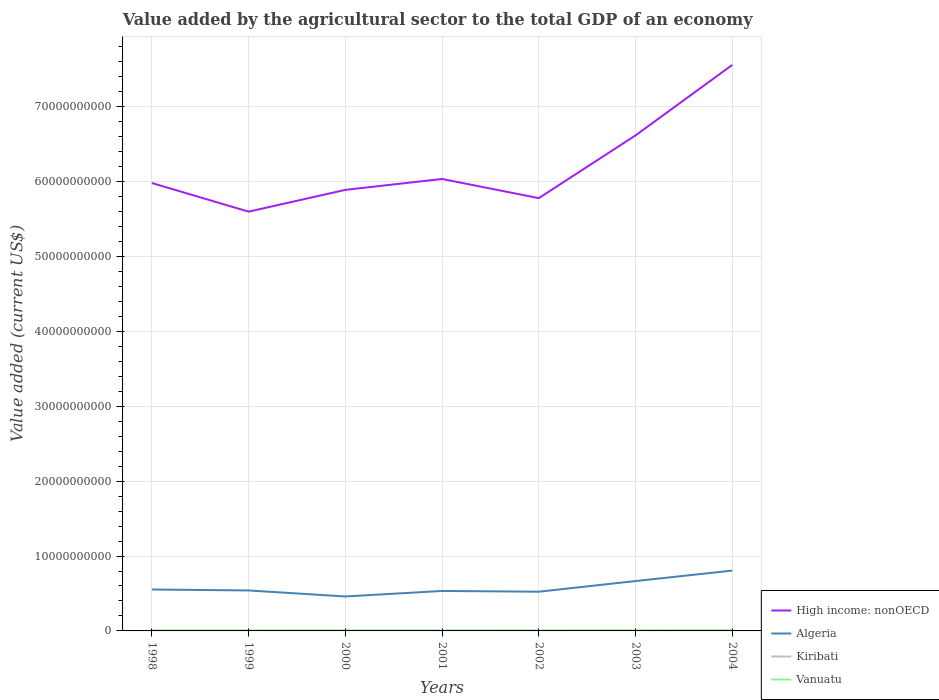How many different coloured lines are there?
Provide a short and direct response. 4. Does the line corresponding to Vanuatu intersect with the line corresponding to High income: nonOECD?
Make the answer very short. No. Across all years, what is the maximum value added by the agricultural sector to the total GDP in Algeria?
Your answer should be very brief. 4.60e+09. What is the total value added by the agricultural sector to the total GDP in High income: nonOECD in the graph?
Provide a short and direct response. 3.82e+09. What is the difference between the highest and the second highest value added by the agricultural sector to the total GDP in Vanuatu?
Give a very brief answer. 2.54e+07. Is the value added by the agricultural sector to the total GDP in Algeria strictly greater than the value added by the agricultural sector to the total GDP in Vanuatu over the years?
Offer a terse response. No. How many years are there in the graph?
Your response must be concise. 7. What is the difference between two consecutive major ticks on the Y-axis?
Give a very brief answer. 1.00e+1. Are the values on the major ticks of Y-axis written in scientific E-notation?
Your response must be concise. No. Does the graph contain grids?
Provide a short and direct response. Yes. How many legend labels are there?
Provide a succinct answer. 4. What is the title of the graph?
Provide a short and direct response. Value added by the agricultural sector to the total GDP of an economy. Does "Armenia" appear as one of the legend labels in the graph?
Your answer should be compact. No. What is the label or title of the X-axis?
Give a very brief answer. Years. What is the label or title of the Y-axis?
Offer a terse response. Value added (current US$). What is the Value added (current US$) of High income: nonOECD in 1998?
Provide a succinct answer. 5.98e+1. What is the Value added (current US$) in Algeria in 1998?
Your answer should be very brief. 5.53e+09. What is the Value added (current US$) of Kiribati in 1998?
Give a very brief answer. 1.59e+07. What is the Value added (current US$) in Vanuatu in 1998?
Your response must be concise. 6.85e+07. What is the Value added (current US$) in High income: nonOECD in 1999?
Ensure brevity in your answer.  5.60e+1. What is the Value added (current US$) in Algeria in 1999?
Your answer should be very brief. 5.40e+09. What is the Value added (current US$) of Kiribati in 1999?
Give a very brief answer. 1.74e+07. What is the Value added (current US$) of Vanuatu in 1999?
Provide a short and direct response. 6.66e+07. What is the Value added (current US$) of High income: nonOECD in 2000?
Ensure brevity in your answer.  5.89e+1. What is the Value added (current US$) of Algeria in 2000?
Offer a terse response. 4.60e+09. What is the Value added (current US$) of Kiribati in 2000?
Your answer should be compact. 1.34e+07. What is the Value added (current US$) in Vanuatu in 2000?
Offer a very short reply. 6.25e+07. What is the Value added (current US$) of High income: nonOECD in 2001?
Offer a very short reply. 6.03e+1. What is the Value added (current US$) of Algeria in 2001?
Your answer should be very brief. 5.34e+09. What is the Value added (current US$) in Kiribati in 2001?
Your answer should be very brief. 1.29e+07. What is the Value added (current US$) in Vanuatu in 2001?
Make the answer very short. 6.07e+07. What is the Value added (current US$) in High income: nonOECD in 2002?
Provide a succinct answer. 5.78e+1. What is the Value added (current US$) of Algeria in 2002?
Your answer should be very brief. 5.24e+09. What is the Value added (current US$) of Kiribati in 2002?
Give a very brief answer. 1.56e+07. What is the Value added (current US$) of Vanuatu in 2002?
Ensure brevity in your answer.  6.37e+07. What is the Value added (current US$) of High income: nonOECD in 2003?
Your answer should be compact. 6.62e+1. What is the Value added (current US$) in Algeria in 2003?
Ensure brevity in your answer.  6.66e+09. What is the Value added (current US$) in Kiribati in 2003?
Ensure brevity in your answer.  2.12e+07. What is the Value added (current US$) of Vanuatu in 2003?
Ensure brevity in your answer.  7.18e+07. What is the Value added (current US$) of High income: nonOECD in 2004?
Provide a short and direct response. 7.56e+1. What is the Value added (current US$) of Algeria in 2004?
Offer a very short reply. 8.06e+09. What is the Value added (current US$) in Kiribati in 2004?
Your response must be concise. 2.50e+07. What is the Value added (current US$) of Vanuatu in 2004?
Make the answer very short. 8.61e+07. Across all years, what is the maximum Value added (current US$) of High income: nonOECD?
Your answer should be compact. 7.56e+1. Across all years, what is the maximum Value added (current US$) of Algeria?
Offer a very short reply. 8.06e+09. Across all years, what is the maximum Value added (current US$) of Kiribati?
Provide a short and direct response. 2.50e+07. Across all years, what is the maximum Value added (current US$) in Vanuatu?
Offer a terse response. 8.61e+07. Across all years, what is the minimum Value added (current US$) in High income: nonOECD?
Ensure brevity in your answer.  5.60e+1. Across all years, what is the minimum Value added (current US$) in Algeria?
Make the answer very short. 4.60e+09. Across all years, what is the minimum Value added (current US$) in Kiribati?
Provide a short and direct response. 1.29e+07. Across all years, what is the minimum Value added (current US$) of Vanuatu?
Provide a succinct answer. 6.07e+07. What is the total Value added (current US$) in High income: nonOECD in the graph?
Provide a short and direct response. 4.35e+11. What is the total Value added (current US$) of Algeria in the graph?
Provide a short and direct response. 4.08e+1. What is the total Value added (current US$) in Kiribati in the graph?
Provide a succinct answer. 1.21e+08. What is the total Value added (current US$) of Vanuatu in the graph?
Make the answer very short. 4.80e+08. What is the difference between the Value added (current US$) in High income: nonOECD in 1998 and that in 1999?
Give a very brief answer. 3.82e+09. What is the difference between the Value added (current US$) of Algeria in 1998 and that in 1999?
Provide a short and direct response. 1.27e+08. What is the difference between the Value added (current US$) of Kiribati in 1998 and that in 1999?
Provide a succinct answer. -1.44e+06. What is the difference between the Value added (current US$) of Vanuatu in 1998 and that in 1999?
Offer a very short reply. 1.86e+06. What is the difference between the Value added (current US$) in High income: nonOECD in 1998 and that in 2000?
Offer a terse response. 9.12e+08. What is the difference between the Value added (current US$) in Algeria in 1998 and that in 2000?
Keep it short and to the point. 9.29e+08. What is the difference between the Value added (current US$) in Kiribati in 1998 and that in 2000?
Your answer should be compact. 2.51e+06. What is the difference between the Value added (current US$) of Vanuatu in 1998 and that in 2000?
Offer a very short reply. 5.99e+06. What is the difference between the Value added (current US$) in High income: nonOECD in 1998 and that in 2001?
Offer a very short reply. -5.42e+08. What is the difference between the Value added (current US$) in Algeria in 1998 and that in 2001?
Your response must be concise. 1.92e+08. What is the difference between the Value added (current US$) in Kiribati in 1998 and that in 2001?
Provide a succinct answer. 3.06e+06. What is the difference between the Value added (current US$) of Vanuatu in 1998 and that in 2001?
Your answer should be compact. 7.76e+06. What is the difference between the Value added (current US$) of High income: nonOECD in 1998 and that in 2002?
Make the answer very short. 2.02e+09. What is the difference between the Value added (current US$) of Algeria in 1998 and that in 2002?
Keep it short and to the point. 2.93e+08. What is the difference between the Value added (current US$) of Kiribati in 1998 and that in 2002?
Your answer should be compact. 2.98e+05. What is the difference between the Value added (current US$) of Vanuatu in 1998 and that in 2002?
Your answer should be very brief. 4.73e+06. What is the difference between the Value added (current US$) in High income: nonOECD in 1998 and that in 2003?
Offer a terse response. -6.36e+09. What is the difference between the Value added (current US$) in Algeria in 1998 and that in 2003?
Your answer should be compact. -1.13e+09. What is the difference between the Value added (current US$) in Kiribati in 1998 and that in 2003?
Give a very brief answer. -5.22e+06. What is the difference between the Value added (current US$) of Vanuatu in 1998 and that in 2003?
Your answer should be very brief. -3.34e+06. What is the difference between the Value added (current US$) of High income: nonOECD in 1998 and that in 2004?
Give a very brief answer. -1.58e+1. What is the difference between the Value added (current US$) of Algeria in 1998 and that in 2004?
Give a very brief answer. -2.53e+09. What is the difference between the Value added (current US$) of Kiribati in 1998 and that in 2004?
Offer a terse response. -9.05e+06. What is the difference between the Value added (current US$) in Vanuatu in 1998 and that in 2004?
Provide a succinct answer. -1.77e+07. What is the difference between the Value added (current US$) in High income: nonOECD in 1999 and that in 2000?
Provide a succinct answer. -2.91e+09. What is the difference between the Value added (current US$) in Algeria in 1999 and that in 2000?
Your answer should be compact. 8.03e+08. What is the difference between the Value added (current US$) of Kiribati in 1999 and that in 2000?
Provide a succinct answer. 3.95e+06. What is the difference between the Value added (current US$) of Vanuatu in 1999 and that in 2000?
Give a very brief answer. 4.12e+06. What is the difference between the Value added (current US$) of High income: nonOECD in 1999 and that in 2001?
Offer a very short reply. -4.36e+09. What is the difference between the Value added (current US$) in Algeria in 1999 and that in 2001?
Your response must be concise. 6.57e+07. What is the difference between the Value added (current US$) of Kiribati in 1999 and that in 2001?
Provide a short and direct response. 4.50e+06. What is the difference between the Value added (current US$) in Vanuatu in 1999 and that in 2001?
Offer a very short reply. 5.90e+06. What is the difference between the Value added (current US$) of High income: nonOECD in 1999 and that in 2002?
Your answer should be compact. -1.80e+09. What is the difference between the Value added (current US$) of Algeria in 1999 and that in 2002?
Provide a short and direct response. 1.67e+08. What is the difference between the Value added (current US$) in Kiribati in 1999 and that in 2002?
Make the answer very short. 1.74e+06. What is the difference between the Value added (current US$) in Vanuatu in 1999 and that in 2002?
Give a very brief answer. 2.87e+06. What is the difference between the Value added (current US$) in High income: nonOECD in 1999 and that in 2003?
Your response must be concise. -1.02e+1. What is the difference between the Value added (current US$) in Algeria in 1999 and that in 2003?
Provide a succinct answer. -1.25e+09. What is the difference between the Value added (current US$) of Kiribati in 1999 and that in 2003?
Ensure brevity in your answer.  -3.79e+06. What is the difference between the Value added (current US$) of Vanuatu in 1999 and that in 2003?
Make the answer very short. -5.20e+06. What is the difference between the Value added (current US$) of High income: nonOECD in 1999 and that in 2004?
Provide a succinct answer. -1.96e+1. What is the difference between the Value added (current US$) of Algeria in 1999 and that in 2004?
Your answer should be very brief. -2.65e+09. What is the difference between the Value added (current US$) of Kiribati in 1999 and that in 2004?
Offer a terse response. -7.61e+06. What is the difference between the Value added (current US$) of Vanuatu in 1999 and that in 2004?
Your answer should be very brief. -1.95e+07. What is the difference between the Value added (current US$) in High income: nonOECD in 2000 and that in 2001?
Your response must be concise. -1.45e+09. What is the difference between the Value added (current US$) of Algeria in 2000 and that in 2001?
Your response must be concise. -7.37e+08. What is the difference between the Value added (current US$) of Kiribati in 2000 and that in 2001?
Provide a succinct answer. 5.52e+05. What is the difference between the Value added (current US$) in Vanuatu in 2000 and that in 2001?
Your answer should be compact. 1.78e+06. What is the difference between the Value added (current US$) in High income: nonOECD in 2000 and that in 2002?
Provide a succinct answer. 1.11e+09. What is the difference between the Value added (current US$) in Algeria in 2000 and that in 2002?
Ensure brevity in your answer.  -6.36e+08. What is the difference between the Value added (current US$) in Kiribati in 2000 and that in 2002?
Your answer should be very brief. -2.21e+06. What is the difference between the Value added (current US$) of Vanuatu in 2000 and that in 2002?
Your answer should be very brief. -1.26e+06. What is the difference between the Value added (current US$) in High income: nonOECD in 2000 and that in 2003?
Your answer should be very brief. -7.27e+09. What is the difference between the Value added (current US$) in Algeria in 2000 and that in 2003?
Provide a short and direct response. -2.06e+09. What is the difference between the Value added (current US$) of Kiribati in 2000 and that in 2003?
Keep it short and to the point. -7.73e+06. What is the difference between the Value added (current US$) of Vanuatu in 2000 and that in 2003?
Offer a terse response. -9.32e+06. What is the difference between the Value added (current US$) of High income: nonOECD in 2000 and that in 2004?
Give a very brief answer. -1.67e+1. What is the difference between the Value added (current US$) in Algeria in 2000 and that in 2004?
Keep it short and to the point. -3.46e+09. What is the difference between the Value added (current US$) in Kiribati in 2000 and that in 2004?
Offer a terse response. -1.16e+07. What is the difference between the Value added (current US$) in Vanuatu in 2000 and that in 2004?
Provide a short and direct response. -2.37e+07. What is the difference between the Value added (current US$) of High income: nonOECD in 2001 and that in 2002?
Your answer should be compact. 2.56e+09. What is the difference between the Value added (current US$) in Algeria in 2001 and that in 2002?
Ensure brevity in your answer.  1.01e+08. What is the difference between the Value added (current US$) in Kiribati in 2001 and that in 2002?
Give a very brief answer. -2.76e+06. What is the difference between the Value added (current US$) of Vanuatu in 2001 and that in 2002?
Ensure brevity in your answer.  -3.03e+06. What is the difference between the Value added (current US$) in High income: nonOECD in 2001 and that in 2003?
Give a very brief answer. -5.82e+09. What is the difference between the Value added (current US$) of Algeria in 2001 and that in 2003?
Provide a succinct answer. -1.32e+09. What is the difference between the Value added (current US$) in Kiribati in 2001 and that in 2003?
Provide a short and direct response. -8.29e+06. What is the difference between the Value added (current US$) in Vanuatu in 2001 and that in 2003?
Your response must be concise. -1.11e+07. What is the difference between the Value added (current US$) of High income: nonOECD in 2001 and that in 2004?
Give a very brief answer. -1.52e+1. What is the difference between the Value added (current US$) in Algeria in 2001 and that in 2004?
Keep it short and to the point. -2.72e+09. What is the difference between the Value added (current US$) in Kiribati in 2001 and that in 2004?
Offer a very short reply. -1.21e+07. What is the difference between the Value added (current US$) of Vanuatu in 2001 and that in 2004?
Provide a short and direct response. -2.54e+07. What is the difference between the Value added (current US$) of High income: nonOECD in 2002 and that in 2003?
Provide a succinct answer. -8.38e+09. What is the difference between the Value added (current US$) in Algeria in 2002 and that in 2003?
Give a very brief answer. -1.42e+09. What is the difference between the Value added (current US$) of Kiribati in 2002 and that in 2003?
Offer a very short reply. -5.52e+06. What is the difference between the Value added (current US$) of Vanuatu in 2002 and that in 2003?
Give a very brief answer. -8.07e+06. What is the difference between the Value added (current US$) of High income: nonOECD in 2002 and that in 2004?
Offer a very short reply. -1.78e+1. What is the difference between the Value added (current US$) in Algeria in 2002 and that in 2004?
Your answer should be very brief. -2.82e+09. What is the difference between the Value added (current US$) in Kiribati in 2002 and that in 2004?
Make the answer very short. -9.35e+06. What is the difference between the Value added (current US$) in Vanuatu in 2002 and that in 2004?
Your answer should be compact. -2.24e+07. What is the difference between the Value added (current US$) in High income: nonOECD in 2003 and that in 2004?
Ensure brevity in your answer.  -9.41e+09. What is the difference between the Value added (current US$) of Algeria in 2003 and that in 2004?
Provide a succinct answer. -1.40e+09. What is the difference between the Value added (current US$) of Kiribati in 2003 and that in 2004?
Your answer should be very brief. -3.82e+06. What is the difference between the Value added (current US$) in Vanuatu in 2003 and that in 2004?
Offer a very short reply. -1.43e+07. What is the difference between the Value added (current US$) in High income: nonOECD in 1998 and the Value added (current US$) in Algeria in 1999?
Ensure brevity in your answer.  5.44e+1. What is the difference between the Value added (current US$) of High income: nonOECD in 1998 and the Value added (current US$) of Kiribati in 1999?
Give a very brief answer. 5.98e+1. What is the difference between the Value added (current US$) in High income: nonOECD in 1998 and the Value added (current US$) in Vanuatu in 1999?
Keep it short and to the point. 5.97e+1. What is the difference between the Value added (current US$) in Algeria in 1998 and the Value added (current US$) in Kiribati in 1999?
Offer a very short reply. 5.51e+09. What is the difference between the Value added (current US$) of Algeria in 1998 and the Value added (current US$) of Vanuatu in 1999?
Give a very brief answer. 5.46e+09. What is the difference between the Value added (current US$) in Kiribati in 1998 and the Value added (current US$) in Vanuatu in 1999?
Make the answer very short. -5.07e+07. What is the difference between the Value added (current US$) in High income: nonOECD in 1998 and the Value added (current US$) in Algeria in 2000?
Give a very brief answer. 5.52e+1. What is the difference between the Value added (current US$) in High income: nonOECD in 1998 and the Value added (current US$) in Kiribati in 2000?
Offer a terse response. 5.98e+1. What is the difference between the Value added (current US$) in High income: nonOECD in 1998 and the Value added (current US$) in Vanuatu in 2000?
Ensure brevity in your answer.  5.97e+1. What is the difference between the Value added (current US$) in Algeria in 1998 and the Value added (current US$) in Kiribati in 2000?
Offer a terse response. 5.52e+09. What is the difference between the Value added (current US$) of Algeria in 1998 and the Value added (current US$) of Vanuatu in 2000?
Keep it short and to the point. 5.47e+09. What is the difference between the Value added (current US$) of Kiribati in 1998 and the Value added (current US$) of Vanuatu in 2000?
Ensure brevity in your answer.  -4.65e+07. What is the difference between the Value added (current US$) of High income: nonOECD in 1998 and the Value added (current US$) of Algeria in 2001?
Offer a terse response. 5.45e+1. What is the difference between the Value added (current US$) in High income: nonOECD in 1998 and the Value added (current US$) in Kiribati in 2001?
Offer a terse response. 5.98e+1. What is the difference between the Value added (current US$) of High income: nonOECD in 1998 and the Value added (current US$) of Vanuatu in 2001?
Your answer should be very brief. 5.97e+1. What is the difference between the Value added (current US$) in Algeria in 1998 and the Value added (current US$) in Kiribati in 2001?
Offer a terse response. 5.52e+09. What is the difference between the Value added (current US$) in Algeria in 1998 and the Value added (current US$) in Vanuatu in 2001?
Keep it short and to the point. 5.47e+09. What is the difference between the Value added (current US$) of Kiribati in 1998 and the Value added (current US$) of Vanuatu in 2001?
Offer a very short reply. -4.48e+07. What is the difference between the Value added (current US$) in High income: nonOECD in 1998 and the Value added (current US$) in Algeria in 2002?
Offer a terse response. 5.46e+1. What is the difference between the Value added (current US$) in High income: nonOECD in 1998 and the Value added (current US$) in Kiribati in 2002?
Give a very brief answer. 5.98e+1. What is the difference between the Value added (current US$) of High income: nonOECD in 1998 and the Value added (current US$) of Vanuatu in 2002?
Keep it short and to the point. 5.97e+1. What is the difference between the Value added (current US$) in Algeria in 1998 and the Value added (current US$) in Kiribati in 2002?
Provide a succinct answer. 5.51e+09. What is the difference between the Value added (current US$) in Algeria in 1998 and the Value added (current US$) in Vanuatu in 2002?
Provide a succinct answer. 5.47e+09. What is the difference between the Value added (current US$) of Kiribati in 1998 and the Value added (current US$) of Vanuatu in 2002?
Keep it short and to the point. -4.78e+07. What is the difference between the Value added (current US$) of High income: nonOECD in 1998 and the Value added (current US$) of Algeria in 2003?
Provide a succinct answer. 5.31e+1. What is the difference between the Value added (current US$) in High income: nonOECD in 1998 and the Value added (current US$) in Kiribati in 2003?
Ensure brevity in your answer.  5.98e+1. What is the difference between the Value added (current US$) in High income: nonOECD in 1998 and the Value added (current US$) in Vanuatu in 2003?
Your response must be concise. 5.97e+1. What is the difference between the Value added (current US$) in Algeria in 1998 and the Value added (current US$) in Kiribati in 2003?
Your answer should be very brief. 5.51e+09. What is the difference between the Value added (current US$) of Algeria in 1998 and the Value added (current US$) of Vanuatu in 2003?
Make the answer very short. 5.46e+09. What is the difference between the Value added (current US$) in Kiribati in 1998 and the Value added (current US$) in Vanuatu in 2003?
Your response must be concise. -5.59e+07. What is the difference between the Value added (current US$) in High income: nonOECD in 1998 and the Value added (current US$) in Algeria in 2004?
Offer a very short reply. 5.17e+1. What is the difference between the Value added (current US$) of High income: nonOECD in 1998 and the Value added (current US$) of Kiribati in 2004?
Provide a short and direct response. 5.98e+1. What is the difference between the Value added (current US$) of High income: nonOECD in 1998 and the Value added (current US$) of Vanuatu in 2004?
Your answer should be compact. 5.97e+1. What is the difference between the Value added (current US$) in Algeria in 1998 and the Value added (current US$) in Kiribati in 2004?
Offer a very short reply. 5.50e+09. What is the difference between the Value added (current US$) of Algeria in 1998 and the Value added (current US$) of Vanuatu in 2004?
Your answer should be very brief. 5.44e+09. What is the difference between the Value added (current US$) of Kiribati in 1998 and the Value added (current US$) of Vanuatu in 2004?
Provide a succinct answer. -7.02e+07. What is the difference between the Value added (current US$) of High income: nonOECD in 1999 and the Value added (current US$) of Algeria in 2000?
Give a very brief answer. 5.14e+1. What is the difference between the Value added (current US$) in High income: nonOECD in 1999 and the Value added (current US$) in Kiribati in 2000?
Your response must be concise. 5.60e+1. What is the difference between the Value added (current US$) of High income: nonOECD in 1999 and the Value added (current US$) of Vanuatu in 2000?
Keep it short and to the point. 5.59e+1. What is the difference between the Value added (current US$) in Algeria in 1999 and the Value added (current US$) in Kiribati in 2000?
Provide a succinct answer. 5.39e+09. What is the difference between the Value added (current US$) of Algeria in 1999 and the Value added (current US$) of Vanuatu in 2000?
Make the answer very short. 5.34e+09. What is the difference between the Value added (current US$) in Kiribati in 1999 and the Value added (current US$) in Vanuatu in 2000?
Provide a succinct answer. -4.51e+07. What is the difference between the Value added (current US$) of High income: nonOECD in 1999 and the Value added (current US$) of Algeria in 2001?
Keep it short and to the point. 5.06e+1. What is the difference between the Value added (current US$) in High income: nonOECD in 1999 and the Value added (current US$) in Kiribati in 2001?
Ensure brevity in your answer.  5.60e+1. What is the difference between the Value added (current US$) in High income: nonOECD in 1999 and the Value added (current US$) in Vanuatu in 2001?
Offer a terse response. 5.59e+1. What is the difference between the Value added (current US$) in Algeria in 1999 and the Value added (current US$) in Kiribati in 2001?
Provide a short and direct response. 5.39e+09. What is the difference between the Value added (current US$) of Algeria in 1999 and the Value added (current US$) of Vanuatu in 2001?
Provide a short and direct response. 5.34e+09. What is the difference between the Value added (current US$) in Kiribati in 1999 and the Value added (current US$) in Vanuatu in 2001?
Provide a short and direct response. -4.33e+07. What is the difference between the Value added (current US$) in High income: nonOECD in 1999 and the Value added (current US$) in Algeria in 2002?
Ensure brevity in your answer.  5.07e+1. What is the difference between the Value added (current US$) of High income: nonOECD in 1999 and the Value added (current US$) of Kiribati in 2002?
Ensure brevity in your answer.  5.60e+1. What is the difference between the Value added (current US$) of High income: nonOECD in 1999 and the Value added (current US$) of Vanuatu in 2002?
Give a very brief answer. 5.59e+1. What is the difference between the Value added (current US$) in Algeria in 1999 and the Value added (current US$) in Kiribati in 2002?
Keep it short and to the point. 5.39e+09. What is the difference between the Value added (current US$) of Algeria in 1999 and the Value added (current US$) of Vanuatu in 2002?
Offer a terse response. 5.34e+09. What is the difference between the Value added (current US$) of Kiribati in 1999 and the Value added (current US$) of Vanuatu in 2002?
Offer a very short reply. -4.64e+07. What is the difference between the Value added (current US$) of High income: nonOECD in 1999 and the Value added (current US$) of Algeria in 2003?
Offer a terse response. 4.93e+1. What is the difference between the Value added (current US$) of High income: nonOECD in 1999 and the Value added (current US$) of Kiribati in 2003?
Offer a terse response. 5.60e+1. What is the difference between the Value added (current US$) in High income: nonOECD in 1999 and the Value added (current US$) in Vanuatu in 2003?
Make the answer very short. 5.59e+1. What is the difference between the Value added (current US$) in Algeria in 1999 and the Value added (current US$) in Kiribati in 2003?
Your response must be concise. 5.38e+09. What is the difference between the Value added (current US$) of Algeria in 1999 and the Value added (current US$) of Vanuatu in 2003?
Ensure brevity in your answer.  5.33e+09. What is the difference between the Value added (current US$) of Kiribati in 1999 and the Value added (current US$) of Vanuatu in 2003?
Keep it short and to the point. -5.44e+07. What is the difference between the Value added (current US$) of High income: nonOECD in 1999 and the Value added (current US$) of Algeria in 2004?
Offer a terse response. 4.79e+1. What is the difference between the Value added (current US$) in High income: nonOECD in 1999 and the Value added (current US$) in Kiribati in 2004?
Offer a terse response. 5.60e+1. What is the difference between the Value added (current US$) of High income: nonOECD in 1999 and the Value added (current US$) of Vanuatu in 2004?
Provide a short and direct response. 5.59e+1. What is the difference between the Value added (current US$) in Algeria in 1999 and the Value added (current US$) in Kiribati in 2004?
Give a very brief answer. 5.38e+09. What is the difference between the Value added (current US$) in Algeria in 1999 and the Value added (current US$) in Vanuatu in 2004?
Your answer should be compact. 5.32e+09. What is the difference between the Value added (current US$) of Kiribati in 1999 and the Value added (current US$) of Vanuatu in 2004?
Your answer should be very brief. -6.88e+07. What is the difference between the Value added (current US$) in High income: nonOECD in 2000 and the Value added (current US$) in Algeria in 2001?
Offer a terse response. 5.36e+1. What is the difference between the Value added (current US$) in High income: nonOECD in 2000 and the Value added (current US$) in Kiribati in 2001?
Your answer should be compact. 5.89e+1. What is the difference between the Value added (current US$) in High income: nonOECD in 2000 and the Value added (current US$) in Vanuatu in 2001?
Ensure brevity in your answer.  5.88e+1. What is the difference between the Value added (current US$) of Algeria in 2000 and the Value added (current US$) of Kiribati in 2001?
Keep it short and to the point. 4.59e+09. What is the difference between the Value added (current US$) in Algeria in 2000 and the Value added (current US$) in Vanuatu in 2001?
Provide a succinct answer. 4.54e+09. What is the difference between the Value added (current US$) in Kiribati in 2000 and the Value added (current US$) in Vanuatu in 2001?
Offer a terse response. -4.73e+07. What is the difference between the Value added (current US$) of High income: nonOECD in 2000 and the Value added (current US$) of Algeria in 2002?
Your answer should be very brief. 5.37e+1. What is the difference between the Value added (current US$) of High income: nonOECD in 2000 and the Value added (current US$) of Kiribati in 2002?
Provide a succinct answer. 5.89e+1. What is the difference between the Value added (current US$) of High income: nonOECD in 2000 and the Value added (current US$) of Vanuatu in 2002?
Offer a terse response. 5.88e+1. What is the difference between the Value added (current US$) in Algeria in 2000 and the Value added (current US$) in Kiribati in 2002?
Give a very brief answer. 4.58e+09. What is the difference between the Value added (current US$) in Algeria in 2000 and the Value added (current US$) in Vanuatu in 2002?
Offer a very short reply. 4.54e+09. What is the difference between the Value added (current US$) in Kiribati in 2000 and the Value added (current US$) in Vanuatu in 2002?
Ensure brevity in your answer.  -5.03e+07. What is the difference between the Value added (current US$) of High income: nonOECD in 2000 and the Value added (current US$) of Algeria in 2003?
Offer a very short reply. 5.22e+1. What is the difference between the Value added (current US$) of High income: nonOECD in 2000 and the Value added (current US$) of Kiribati in 2003?
Offer a terse response. 5.89e+1. What is the difference between the Value added (current US$) in High income: nonOECD in 2000 and the Value added (current US$) in Vanuatu in 2003?
Your answer should be very brief. 5.88e+1. What is the difference between the Value added (current US$) of Algeria in 2000 and the Value added (current US$) of Kiribati in 2003?
Provide a succinct answer. 4.58e+09. What is the difference between the Value added (current US$) of Algeria in 2000 and the Value added (current US$) of Vanuatu in 2003?
Provide a succinct answer. 4.53e+09. What is the difference between the Value added (current US$) of Kiribati in 2000 and the Value added (current US$) of Vanuatu in 2003?
Offer a very short reply. -5.84e+07. What is the difference between the Value added (current US$) of High income: nonOECD in 2000 and the Value added (current US$) of Algeria in 2004?
Make the answer very short. 5.08e+1. What is the difference between the Value added (current US$) of High income: nonOECD in 2000 and the Value added (current US$) of Kiribati in 2004?
Ensure brevity in your answer.  5.89e+1. What is the difference between the Value added (current US$) in High income: nonOECD in 2000 and the Value added (current US$) in Vanuatu in 2004?
Your answer should be very brief. 5.88e+1. What is the difference between the Value added (current US$) in Algeria in 2000 and the Value added (current US$) in Kiribati in 2004?
Make the answer very short. 4.58e+09. What is the difference between the Value added (current US$) of Algeria in 2000 and the Value added (current US$) of Vanuatu in 2004?
Provide a short and direct response. 4.51e+09. What is the difference between the Value added (current US$) in Kiribati in 2000 and the Value added (current US$) in Vanuatu in 2004?
Your response must be concise. -7.27e+07. What is the difference between the Value added (current US$) in High income: nonOECD in 2001 and the Value added (current US$) in Algeria in 2002?
Ensure brevity in your answer.  5.51e+1. What is the difference between the Value added (current US$) of High income: nonOECD in 2001 and the Value added (current US$) of Kiribati in 2002?
Give a very brief answer. 6.03e+1. What is the difference between the Value added (current US$) of High income: nonOECD in 2001 and the Value added (current US$) of Vanuatu in 2002?
Provide a short and direct response. 6.03e+1. What is the difference between the Value added (current US$) in Algeria in 2001 and the Value added (current US$) in Kiribati in 2002?
Your response must be concise. 5.32e+09. What is the difference between the Value added (current US$) of Algeria in 2001 and the Value added (current US$) of Vanuatu in 2002?
Provide a short and direct response. 5.27e+09. What is the difference between the Value added (current US$) in Kiribati in 2001 and the Value added (current US$) in Vanuatu in 2002?
Your answer should be compact. -5.09e+07. What is the difference between the Value added (current US$) of High income: nonOECD in 2001 and the Value added (current US$) of Algeria in 2003?
Your answer should be compact. 5.37e+1. What is the difference between the Value added (current US$) of High income: nonOECD in 2001 and the Value added (current US$) of Kiribati in 2003?
Your answer should be compact. 6.03e+1. What is the difference between the Value added (current US$) in High income: nonOECD in 2001 and the Value added (current US$) in Vanuatu in 2003?
Give a very brief answer. 6.03e+1. What is the difference between the Value added (current US$) of Algeria in 2001 and the Value added (current US$) of Kiribati in 2003?
Ensure brevity in your answer.  5.32e+09. What is the difference between the Value added (current US$) in Algeria in 2001 and the Value added (current US$) in Vanuatu in 2003?
Your answer should be compact. 5.27e+09. What is the difference between the Value added (current US$) in Kiribati in 2001 and the Value added (current US$) in Vanuatu in 2003?
Provide a succinct answer. -5.89e+07. What is the difference between the Value added (current US$) in High income: nonOECD in 2001 and the Value added (current US$) in Algeria in 2004?
Your response must be concise. 5.23e+1. What is the difference between the Value added (current US$) of High income: nonOECD in 2001 and the Value added (current US$) of Kiribati in 2004?
Make the answer very short. 6.03e+1. What is the difference between the Value added (current US$) of High income: nonOECD in 2001 and the Value added (current US$) of Vanuatu in 2004?
Offer a very short reply. 6.03e+1. What is the difference between the Value added (current US$) of Algeria in 2001 and the Value added (current US$) of Kiribati in 2004?
Make the answer very short. 5.31e+09. What is the difference between the Value added (current US$) in Algeria in 2001 and the Value added (current US$) in Vanuatu in 2004?
Keep it short and to the point. 5.25e+09. What is the difference between the Value added (current US$) of Kiribati in 2001 and the Value added (current US$) of Vanuatu in 2004?
Make the answer very short. -7.33e+07. What is the difference between the Value added (current US$) of High income: nonOECD in 2002 and the Value added (current US$) of Algeria in 2003?
Provide a succinct answer. 5.11e+1. What is the difference between the Value added (current US$) in High income: nonOECD in 2002 and the Value added (current US$) in Kiribati in 2003?
Ensure brevity in your answer.  5.78e+1. What is the difference between the Value added (current US$) in High income: nonOECD in 2002 and the Value added (current US$) in Vanuatu in 2003?
Your answer should be compact. 5.77e+1. What is the difference between the Value added (current US$) in Algeria in 2002 and the Value added (current US$) in Kiribati in 2003?
Your response must be concise. 5.21e+09. What is the difference between the Value added (current US$) in Algeria in 2002 and the Value added (current US$) in Vanuatu in 2003?
Give a very brief answer. 5.16e+09. What is the difference between the Value added (current US$) in Kiribati in 2002 and the Value added (current US$) in Vanuatu in 2003?
Provide a succinct answer. -5.62e+07. What is the difference between the Value added (current US$) of High income: nonOECD in 2002 and the Value added (current US$) of Algeria in 2004?
Give a very brief answer. 4.97e+1. What is the difference between the Value added (current US$) in High income: nonOECD in 2002 and the Value added (current US$) in Kiribati in 2004?
Give a very brief answer. 5.78e+1. What is the difference between the Value added (current US$) of High income: nonOECD in 2002 and the Value added (current US$) of Vanuatu in 2004?
Your answer should be very brief. 5.77e+1. What is the difference between the Value added (current US$) of Algeria in 2002 and the Value added (current US$) of Kiribati in 2004?
Ensure brevity in your answer.  5.21e+09. What is the difference between the Value added (current US$) of Algeria in 2002 and the Value added (current US$) of Vanuatu in 2004?
Offer a terse response. 5.15e+09. What is the difference between the Value added (current US$) of Kiribati in 2002 and the Value added (current US$) of Vanuatu in 2004?
Keep it short and to the point. -7.05e+07. What is the difference between the Value added (current US$) in High income: nonOECD in 2003 and the Value added (current US$) in Algeria in 2004?
Offer a very short reply. 5.81e+1. What is the difference between the Value added (current US$) of High income: nonOECD in 2003 and the Value added (current US$) of Kiribati in 2004?
Your response must be concise. 6.61e+1. What is the difference between the Value added (current US$) of High income: nonOECD in 2003 and the Value added (current US$) of Vanuatu in 2004?
Give a very brief answer. 6.61e+1. What is the difference between the Value added (current US$) of Algeria in 2003 and the Value added (current US$) of Kiribati in 2004?
Your response must be concise. 6.63e+09. What is the difference between the Value added (current US$) of Algeria in 2003 and the Value added (current US$) of Vanuatu in 2004?
Your response must be concise. 6.57e+09. What is the difference between the Value added (current US$) in Kiribati in 2003 and the Value added (current US$) in Vanuatu in 2004?
Offer a terse response. -6.50e+07. What is the average Value added (current US$) in High income: nonOECD per year?
Provide a succinct answer. 6.21e+1. What is the average Value added (current US$) of Algeria per year?
Your response must be concise. 5.83e+09. What is the average Value added (current US$) in Kiribati per year?
Keep it short and to the point. 1.73e+07. What is the average Value added (current US$) in Vanuatu per year?
Provide a short and direct response. 6.85e+07. In the year 1998, what is the difference between the Value added (current US$) of High income: nonOECD and Value added (current US$) of Algeria?
Your answer should be compact. 5.43e+1. In the year 1998, what is the difference between the Value added (current US$) of High income: nonOECD and Value added (current US$) of Kiribati?
Offer a very short reply. 5.98e+1. In the year 1998, what is the difference between the Value added (current US$) of High income: nonOECD and Value added (current US$) of Vanuatu?
Your response must be concise. 5.97e+1. In the year 1998, what is the difference between the Value added (current US$) of Algeria and Value added (current US$) of Kiribati?
Offer a very short reply. 5.51e+09. In the year 1998, what is the difference between the Value added (current US$) in Algeria and Value added (current US$) in Vanuatu?
Your response must be concise. 5.46e+09. In the year 1998, what is the difference between the Value added (current US$) in Kiribati and Value added (current US$) in Vanuatu?
Keep it short and to the point. -5.25e+07. In the year 1999, what is the difference between the Value added (current US$) of High income: nonOECD and Value added (current US$) of Algeria?
Keep it short and to the point. 5.06e+1. In the year 1999, what is the difference between the Value added (current US$) in High income: nonOECD and Value added (current US$) in Kiribati?
Your answer should be compact. 5.60e+1. In the year 1999, what is the difference between the Value added (current US$) of High income: nonOECD and Value added (current US$) of Vanuatu?
Offer a terse response. 5.59e+1. In the year 1999, what is the difference between the Value added (current US$) of Algeria and Value added (current US$) of Kiribati?
Your answer should be compact. 5.39e+09. In the year 1999, what is the difference between the Value added (current US$) in Algeria and Value added (current US$) in Vanuatu?
Offer a terse response. 5.34e+09. In the year 1999, what is the difference between the Value added (current US$) of Kiribati and Value added (current US$) of Vanuatu?
Offer a very short reply. -4.92e+07. In the year 2000, what is the difference between the Value added (current US$) in High income: nonOECD and Value added (current US$) in Algeria?
Offer a very short reply. 5.43e+1. In the year 2000, what is the difference between the Value added (current US$) in High income: nonOECD and Value added (current US$) in Kiribati?
Provide a short and direct response. 5.89e+1. In the year 2000, what is the difference between the Value added (current US$) in High income: nonOECD and Value added (current US$) in Vanuatu?
Provide a short and direct response. 5.88e+1. In the year 2000, what is the difference between the Value added (current US$) of Algeria and Value added (current US$) of Kiribati?
Offer a very short reply. 4.59e+09. In the year 2000, what is the difference between the Value added (current US$) of Algeria and Value added (current US$) of Vanuatu?
Your answer should be very brief. 4.54e+09. In the year 2000, what is the difference between the Value added (current US$) in Kiribati and Value added (current US$) in Vanuatu?
Ensure brevity in your answer.  -4.90e+07. In the year 2001, what is the difference between the Value added (current US$) of High income: nonOECD and Value added (current US$) of Algeria?
Provide a short and direct response. 5.50e+1. In the year 2001, what is the difference between the Value added (current US$) of High income: nonOECD and Value added (current US$) of Kiribati?
Offer a very short reply. 6.03e+1. In the year 2001, what is the difference between the Value added (current US$) of High income: nonOECD and Value added (current US$) of Vanuatu?
Provide a short and direct response. 6.03e+1. In the year 2001, what is the difference between the Value added (current US$) of Algeria and Value added (current US$) of Kiribati?
Keep it short and to the point. 5.32e+09. In the year 2001, what is the difference between the Value added (current US$) of Algeria and Value added (current US$) of Vanuatu?
Give a very brief answer. 5.28e+09. In the year 2001, what is the difference between the Value added (current US$) of Kiribati and Value added (current US$) of Vanuatu?
Ensure brevity in your answer.  -4.78e+07. In the year 2002, what is the difference between the Value added (current US$) in High income: nonOECD and Value added (current US$) in Algeria?
Provide a succinct answer. 5.25e+1. In the year 2002, what is the difference between the Value added (current US$) in High income: nonOECD and Value added (current US$) in Kiribati?
Offer a terse response. 5.78e+1. In the year 2002, what is the difference between the Value added (current US$) in High income: nonOECD and Value added (current US$) in Vanuatu?
Offer a terse response. 5.77e+1. In the year 2002, what is the difference between the Value added (current US$) of Algeria and Value added (current US$) of Kiribati?
Keep it short and to the point. 5.22e+09. In the year 2002, what is the difference between the Value added (current US$) of Algeria and Value added (current US$) of Vanuatu?
Ensure brevity in your answer.  5.17e+09. In the year 2002, what is the difference between the Value added (current US$) of Kiribati and Value added (current US$) of Vanuatu?
Make the answer very short. -4.81e+07. In the year 2003, what is the difference between the Value added (current US$) in High income: nonOECD and Value added (current US$) in Algeria?
Provide a short and direct response. 5.95e+1. In the year 2003, what is the difference between the Value added (current US$) of High income: nonOECD and Value added (current US$) of Kiribati?
Your answer should be compact. 6.61e+1. In the year 2003, what is the difference between the Value added (current US$) of High income: nonOECD and Value added (current US$) of Vanuatu?
Offer a terse response. 6.61e+1. In the year 2003, what is the difference between the Value added (current US$) of Algeria and Value added (current US$) of Kiribati?
Ensure brevity in your answer.  6.64e+09. In the year 2003, what is the difference between the Value added (current US$) of Algeria and Value added (current US$) of Vanuatu?
Your answer should be very brief. 6.59e+09. In the year 2003, what is the difference between the Value added (current US$) in Kiribati and Value added (current US$) in Vanuatu?
Offer a very short reply. -5.06e+07. In the year 2004, what is the difference between the Value added (current US$) of High income: nonOECD and Value added (current US$) of Algeria?
Offer a terse response. 6.75e+1. In the year 2004, what is the difference between the Value added (current US$) of High income: nonOECD and Value added (current US$) of Kiribati?
Make the answer very short. 7.56e+1. In the year 2004, what is the difference between the Value added (current US$) of High income: nonOECD and Value added (current US$) of Vanuatu?
Provide a succinct answer. 7.55e+1. In the year 2004, what is the difference between the Value added (current US$) of Algeria and Value added (current US$) of Kiribati?
Offer a terse response. 8.03e+09. In the year 2004, what is the difference between the Value added (current US$) in Algeria and Value added (current US$) in Vanuatu?
Offer a terse response. 7.97e+09. In the year 2004, what is the difference between the Value added (current US$) in Kiribati and Value added (current US$) in Vanuatu?
Provide a short and direct response. -6.12e+07. What is the ratio of the Value added (current US$) in High income: nonOECD in 1998 to that in 1999?
Ensure brevity in your answer.  1.07. What is the ratio of the Value added (current US$) of Algeria in 1998 to that in 1999?
Offer a very short reply. 1.02. What is the ratio of the Value added (current US$) in Kiribati in 1998 to that in 1999?
Provide a succinct answer. 0.92. What is the ratio of the Value added (current US$) of Vanuatu in 1998 to that in 1999?
Ensure brevity in your answer.  1.03. What is the ratio of the Value added (current US$) of High income: nonOECD in 1998 to that in 2000?
Give a very brief answer. 1.02. What is the ratio of the Value added (current US$) of Algeria in 1998 to that in 2000?
Offer a very short reply. 1.2. What is the ratio of the Value added (current US$) of Kiribati in 1998 to that in 2000?
Your answer should be compact. 1.19. What is the ratio of the Value added (current US$) of Vanuatu in 1998 to that in 2000?
Provide a succinct answer. 1.1. What is the ratio of the Value added (current US$) in High income: nonOECD in 1998 to that in 2001?
Offer a terse response. 0.99. What is the ratio of the Value added (current US$) of Algeria in 1998 to that in 2001?
Ensure brevity in your answer.  1.04. What is the ratio of the Value added (current US$) of Kiribati in 1998 to that in 2001?
Your answer should be compact. 1.24. What is the ratio of the Value added (current US$) of Vanuatu in 1998 to that in 2001?
Provide a succinct answer. 1.13. What is the ratio of the Value added (current US$) in High income: nonOECD in 1998 to that in 2002?
Ensure brevity in your answer.  1.03. What is the ratio of the Value added (current US$) of Algeria in 1998 to that in 2002?
Offer a terse response. 1.06. What is the ratio of the Value added (current US$) in Kiribati in 1998 to that in 2002?
Offer a terse response. 1.02. What is the ratio of the Value added (current US$) in Vanuatu in 1998 to that in 2002?
Ensure brevity in your answer.  1.07. What is the ratio of the Value added (current US$) in High income: nonOECD in 1998 to that in 2003?
Your answer should be compact. 0.9. What is the ratio of the Value added (current US$) of Algeria in 1998 to that in 2003?
Your response must be concise. 0.83. What is the ratio of the Value added (current US$) of Kiribati in 1998 to that in 2003?
Offer a very short reply. 0.75. What is the ratio of the Value added (current US$) in Vanuatu in 1998 to that in 2003?
Ensure brevity in your answer.  0.95. What is the ratio of the Value added (current US$) of High income: nonOECD in 1998 to that in 2004?
Offer a terse response. 0.79. What is the ratio of the Value added (current US$) in Algeria in 1998 to that in 2004?
Offer a terse response. 0.69. What is the ratio of the Value added (current US$) in Kiribati in 1998 to that in 2004?
Provide a short and direct response. 0.64. What is the ratio of the Value added (current US$) of Vanuatu in 1998 to that in 2004?
Keep it short and to the point. 0.79. What is the ratio of the Value added (current US$) in High income: nonOECD in 1999 to that in 2000?
Offer a terse response. 0.95. What is the ratio of the Value added (current US$) in Algeria in 1999 to that in 2000?
Make the answer very short. 1.17. What is the ratio of the Value added (current US$) of Kiribati in 1999 to that in 2000?
Provide a short and direct response. 1.29. What is the ratio of the Value added (current US$) of Vanuatu in 1999 to that in 2000?
Provide a short and direct response. 1.07. What is the ratio of the Value added (current US$) in High income: nonOECD in 1999 to that in 2001?
Give a very brief answer. 0.93. What is the ratio of the Value added (current US$) in Algeria in 1999 to that in 2001?
Make the answer very short. 1.01. What is the ratio of the Value added (current US$) in Kiribati in 1999 to that in 2001?
Your answer should be very brief. 1.35. What is the ratio of the Value added (current US$) in Vanuatu in 1999 to that in 2001?
Offer a very short reply. 1.1. What is the ratio of the Value added (current US$) in High income: nonOECD in 1999 to that in 2002?
Give a very brief answer. 0.97. What is the ratio of the Value added (current US$) of Algeria in 1999 to that in 2002?
Ensure brevity in your answer.  1.03. What is the ratio of the Value added (current US$) of Vanuatu in 1999 to that in 2002?
Offer a very short reply. 1.04. What is the ratio of the Value added (current US$) of High income: nonOECD in 1999 to that in 2003?
Your answer should be compact. 0.85. What is the ratio of the Value added (current US$) in Algeria in 1999 to that in 2003?
Provide a short and direct response. 0.81. What is the ratio of the Value added (current US$) of Kiribati in 1999 to that in 2003?
Ensure brevity in your answer.  0.82. What is the ratio of the Value added (current US$) in Vanuatu in 1999 to that in 2003?
Make the answer very short. 0.93. What is the ratio of the Value added (current US$) in High income: nonOECD in 1999 to that in 2004?
Make the answer very short. 0.74. What is the ratio of the Value added (current US$) of Algeria in 1999 to that in 2004?
Your answer should be compact. 0.67. What is the ratio of the Value added (current US$) in Kiribati in 1999 to that in 2004?
Your answer should be compact. 0.7. What is the ratio of the Value added (current US$) of Vanuatu in 1999 to that in 2004?
Provide a short and direct response. 0.77. What is the ratio of the Value added (current US$) in High income: nonOECD in 2000 to that in 2001?
Provide a succinct answer. 0.98. What is the ratio of the Value added (current US$) of Algeria in 2000 to that in 2001?
Your answer should be compact. 0.86. What is the ratio of the Value added (current US$) of Kiribati in 2000 to that in 2001?
Make the answer very short. 1.04. What is the ratio of the Value added (current US$) in Vanuatu in 2000 to that in 2001?
Your answer should be compact. 1.03. What is the ratio of the Value added (current US$) of High income: nonOECD in 2000 to that in 2002?
Provide a succinct answer. 1.02. What is the ratio of the Value added (current US$) in Algeria in 2000 to that in 2002?
Provide a succinct answer. 0.88. What is the ratio of the Value added (current US$) in Kiribati in 2000 to that in 2002?
Provide a short and direct response. 0.86. What is the ratio of the Value added (current US$) in Vanuatu in 2000 to that in 2002?
Offer a terse response. 0.98. What is the ratio of the Value added (current US$) in High income: nonOECD in 2000 to that in 2003?
Ensure brevity in your answer.  0.89. What is the ratio of the Value added (current US$) of Algeria in 2000 to that in 2003?
Provide a succinct answer. 0.69. What is the ratio of the Value added (current US$) in Kiribati in 2000 to that in 2003?
Make the answer very short. 0.63. What is the ratio of the Value added (current US$) of Vanuatu in 2000 to that in 2003?
Give a very brief answer. 0.87. What is the ratio of the Value added (current US$) of High income: nonOECD in 2000 to that in 2004?
Make the answer very short. 0.78. What is the ratio of the Value added (current US$) of Algeria in 2000 to that in 2004?
Provide a succinct answer. 0.57. What is the ratio of the Value added (current US$) of Kiribati in 2000 to that in 2004?
Give a very brief answer. 0.54. What is the ratio of the Value added (current US$) in Vanuatu in 2000 to that in 2004?
Keep it short and to the point. 0.73. What is the ratio of the Value added (current US$) of High income: nonOECD in 2001 to that in 2002?
Your response must be concise. 1.04. What is the ratio of the Value added (current US$) in Algeria in 2001 to that in 2002?
Provide a short and direct response. 1.02. What is the ratio of the Value added (current US$) of Kiribati in 2001 to that in 2002?
Provide a succinct answer. 0.82. What is the ratio of the Value added (current US$) of High income: nonOECD in 2001 to that in 2003?
Give a very brief answer. 0.91. What is the ratio of the Value added (current US$) of Algeria in 2001 to that in 2003?
Make the answer very short. 0.8. What is the ratio of the Value added (current US$) of Kiribati in 2001 to that in 2003?
Make the answer very short. 0.61. What is the ratio of the Value added (current US$) of Vanuatu in 2001 to that in 2003?
Your answer should be compact. 0.85. What is the ratio of the Value added (current US$) in High income: nonOECD in 2001 to that in 2004?
Your answer should be very brief. 0.8. What is the ratio of the Value added (current US$) of Algeria in 2001 to that in 2004?
Ensure brevity in your answer.  0.66. What is the ratio of the Value added (current US$) of Kiribati in 2001 to that in 2004?
Make the answer very short. 0.52. What is the ratio of the Value added (current US$) in Vanuatu in 2001 to that in 2004?
Offer a terse response. 0.7. What is the ratio of the Value added (current US$) of High income: nonOECD in 2002 to that in 2003?
Give a very brief answer. 0.87. What is the ratio of the Value added (current US$) of Algeria in 2002 to that in 2003?
Keep it short and to the point. 0.79. What is the ratio of the Value added (current US$) in Kiribati in 2002 to that in 2003?
Give a very brief answer. 0.74. What is the ratio of the Value added (current US$) of Vanuatu in 2002 to that in 2003?
Ensure brevity in your answer.  0.89. What is the ratio of the Value added (current US$) in High income: nonOECD in 2002 to that in 2004?
Ensure brevity in your answer.  0.76. What is the ratio of the Value added (current US$) of Algeria in 2002 to that in 2004?
Make the answer very short. 0.65. What is the ratio of the Value added (current US$) of Kiribati in 2002 to that in 2004?
Ensure brevity in your answer.  0.63. What is the ratio of the Value added (current US$) in Vanuatu in 2002 to that in 2004?
Ensure brevity in your answer.  0.74. What is the ratio of the Value added (current US$) of High income: nonOECD in 2003 to that in 2004?
Make the answer very short. 0.88. What is the ratio of the Value added (current US$) of Algeria in 2003 to that in 2004?
Provide a succinct answer. 0.83. What is the ratio of the Value added (current US$) in Kiribati in 2003 to that in 2004?
Offer a terse response. 0.85. What is the ratio of the Value added (current US$) in Vanuatu in 2003 to that in 2004?
Your answer should be compact. 0.83. What is the difference between the highest and the second highest Value added (current US$) in High income: nonOECD?
Ensure brevity in your answer.  9.41e+09. What is the difference between the highest and the second highest Value added (current US$) in Algeria?
Provide a succinct answer. 1.40e+09. What is the difference between the highest and the second highest Value added (current US$) in Kiribati?
Make the answer very short. 3.82e+06. What is the difference between the highest and the second highest Value added (current US$) of Vanuatu?
Provide a short and direct response. 1.43e+07. What is the difference between the highest and the lowest Value added (current US$) of High income: nonOECD?
Your answer should be very brief. 1.96e+1. What is the difference between the highest and the lowest Value added (current US$) in Algeria?
Your answer should be compact. 3.46e+09. What is the difference between the highest and the lowest Value added (current US$) of Kiribati?
Keep it short and to the point. 1.21e+07. What is the difference between the highest and the lowest Value added (current US$) of Vanuatu?
Provide a short and direct response. 2.54e+07. 